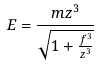<formula> <loc_0><loc_0><loc_500><loc_500>E = \frac { m z ^ { 3 } } { \sqrt { 1 + \frac { f ^ { 3 } } { z ^ { 3 } } } }</formula> 